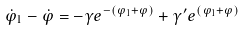Convert formula to latex. <formula><loc_0><loc_0><loc_500><loc_500>\dot { \varphi } _ { 1 } - \dot { \varphi } = - \gamma e ^ { - ( \varphi _ { 1 } + \varphi ) } + \gamma ^ { \prime } e ^ { ( \varphi _ { 1 } + \varphi ) }</formula> 